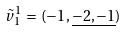<formula> <loc_0><loc_0><loc_500><loc_500>{ \tilde { v } _ { 1 } } ^ { 1 } \, = \, ( { - 1 } , \underline { - 2 , - 1 } )</formula> 